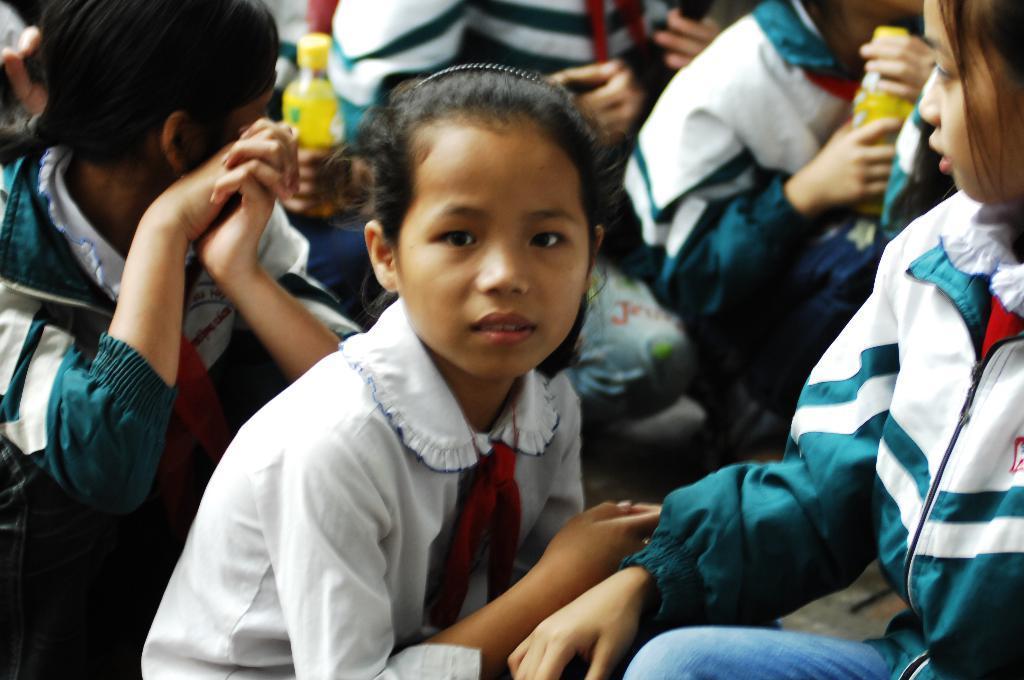In one or two sentences, can you explain what this image depicts? In this picture we can see some people, two persons in the background are holding bottles. 